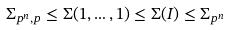<formula> <loc_0><loc_0><loc_500><loc_500>\Sigma _ { p ^ { n } , p } \leq \Sigma ( 1 , \dots , 1 ) \leq \Sigma ( I ) \leq \Sigma _ { p ^ { n } }</formula> 